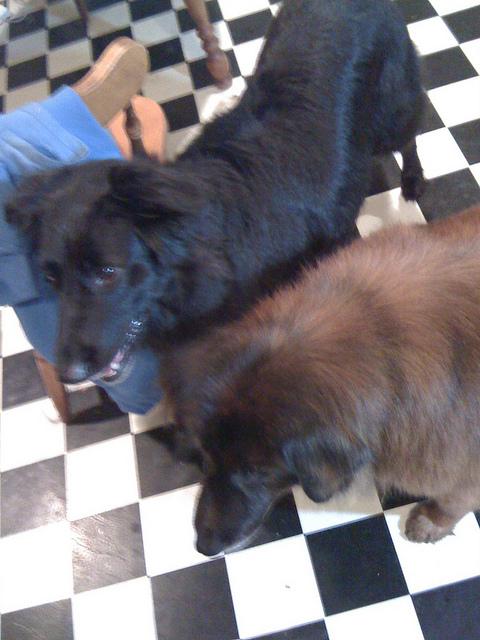What pattern is on the floor beneath the dogs?
Quick response, please. Checkered. What is on the chair?
Answer briefly. Shirt. Could the dogs be hungry?
Write a very short answer. Yes. 